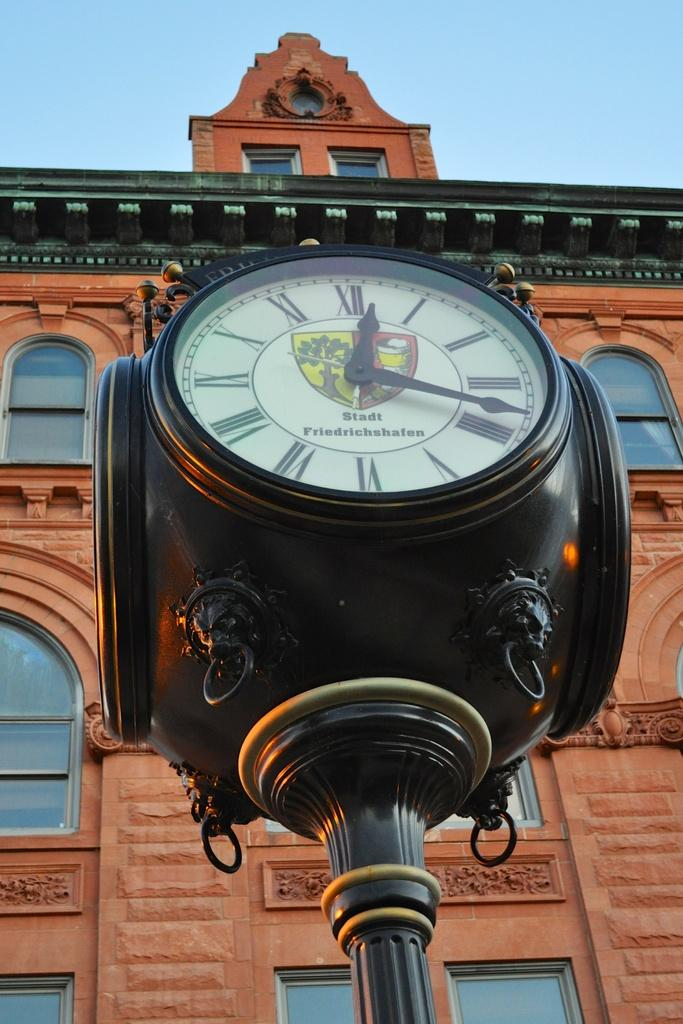What object is present in the image that displays time? There is a wall clock in the image that displays time. What structure can be seen behind the wall clock? There is a building behind the wall clock. What part of the natural environment is visible in the image? The sky is visible in the background of the image. What type of weather can be seen in the image? The provided facts do not mention any specific weather conditions, so it cannot be determined from the image. 